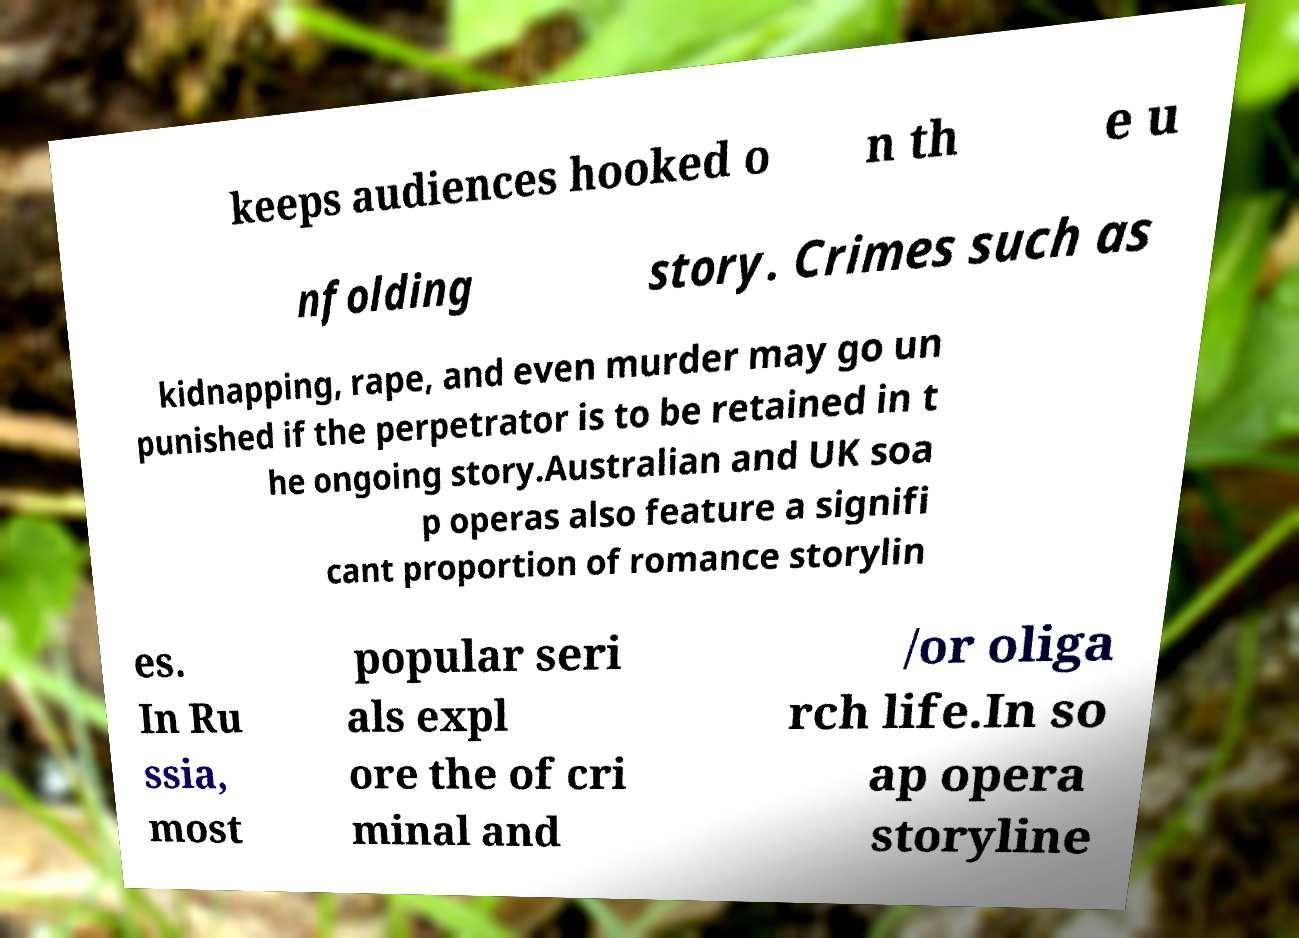There's text embedded in this image that I need extracted. Can you transcribe it verbatim? keeps audiences hooked o n th e u nfolding story. Crimes such as kidnapping, rape, and even murder may go un punished if the perpetrator is to be retained in t he ongoing story.Australian and UK soa p operas also feature a signifi cant proportion of romance storylin es. In Ru ssia, most popular seri als expl ore the of cri minal and /or oliga rch life.In so ap opera storyline 